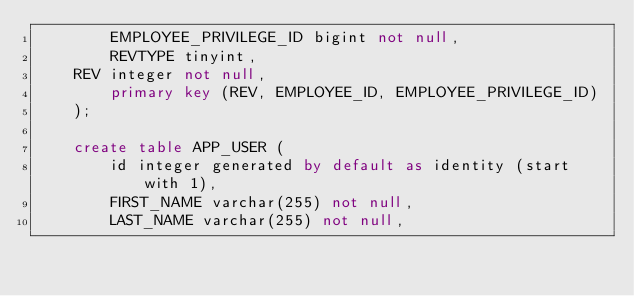<code> <loc_0><loc_0><loc_500><loc_500><_SQL_>        EMPLOYEE_PRIVILEGE_ID bigint not null,
        REVTYPE tinyint,
		REV integer not null,      
        primary key (REV, EMPLOYEE_ID, EMPLOYEE_PRIVILEGE_ID)
    );

    create table APP_USER (
        id integer generated by default as identity (start with 1),
        FIRST_NAME varchar(255) not null,
        LAST_NAME varchar(255) not null,</code> 